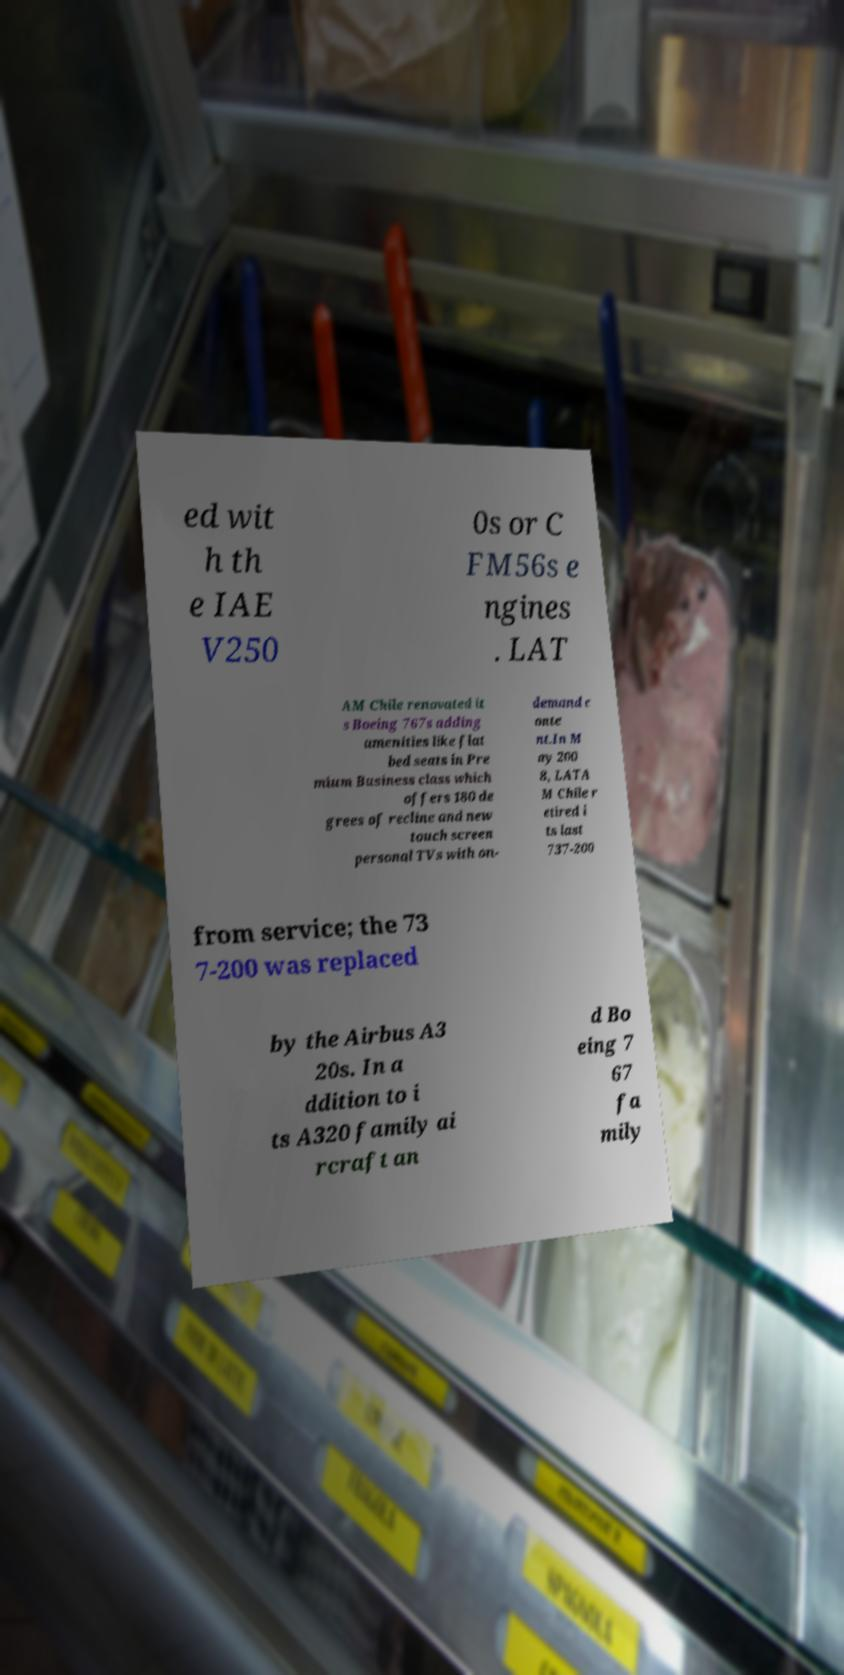Could you extract and type out the text from this image? ed wit h th e IAE V250 0s or C FM56s e ngines . LAT AM Chile renovated it s Boeing 767s adding amenities like flat bed seats in Pre mium Business class which offers 180 de grees of recline and new touch screen personal TVs with on- demand c onte nt.In M ay 200 8, LATA M Chile r etired i ts last 737-200 from service; the 73 7-200 was replaced by the Airbus A3 20s. In a ddition to i ts A320 family ai rcraft an d Bo eing 7 67 fa mily 